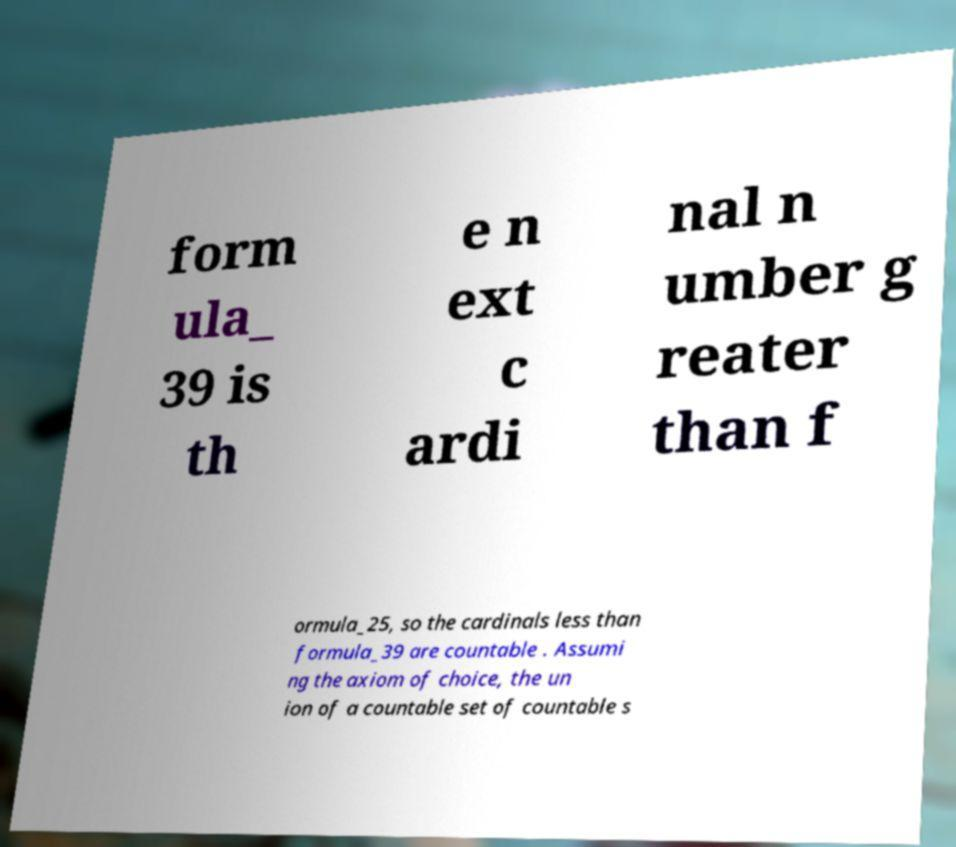Can you read and provide the text displayed in the image?This photo seems to have some interesting text. Can you extract and type it out for me? form ula_ 39 is th e n ext c ardi nal n umber g reater than f ormula_25, so the cardinals less than formula_39 are countable . Assumi ng the axiom of choice, the un ion of a countable set of countable s 